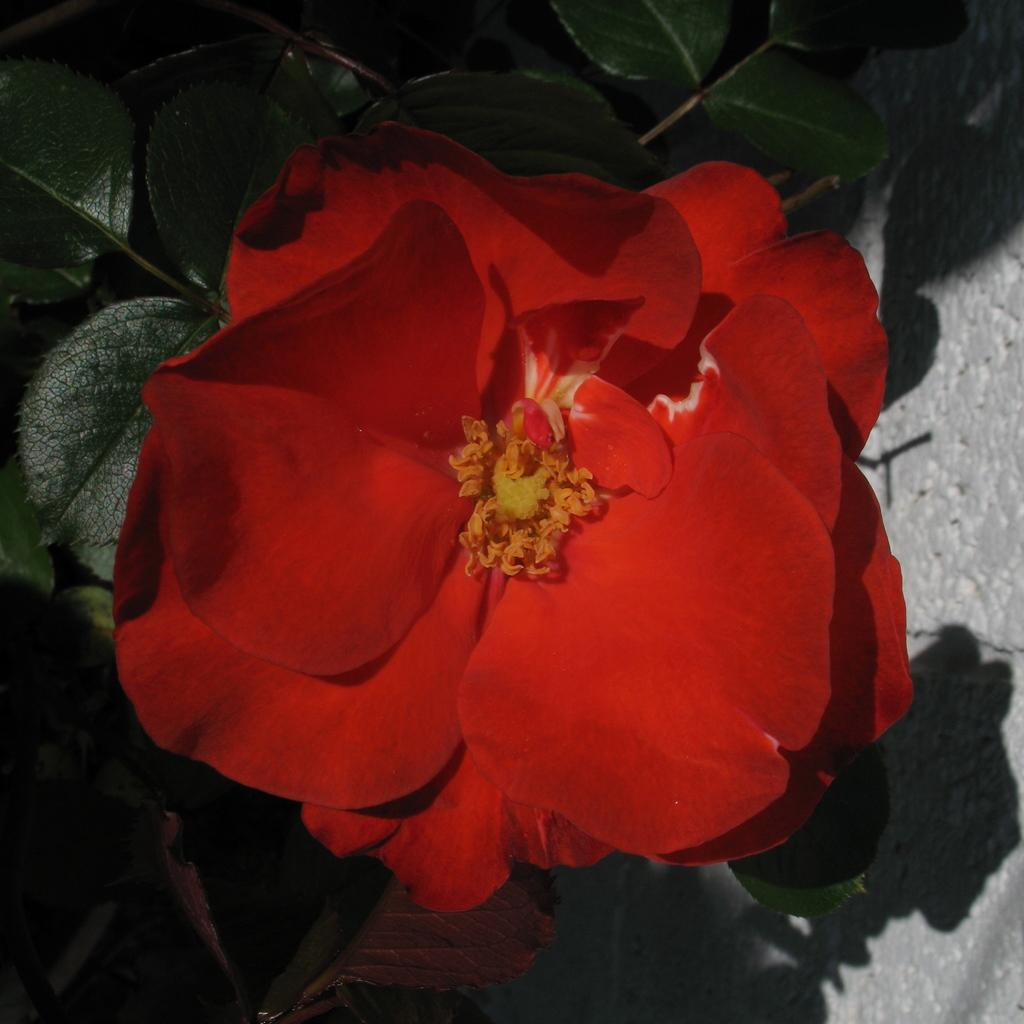What is present in the image? There is a plant in the image. What can be observed about the plant? The plant has a flower, and there is a shadow of the plant on the ground. What type of paste is being used to hold the plant in position in the image? There is no mention of paste or any need to hold the plant in position in the image. The plant is standing on its own, and there is no indication that it requires any support. 